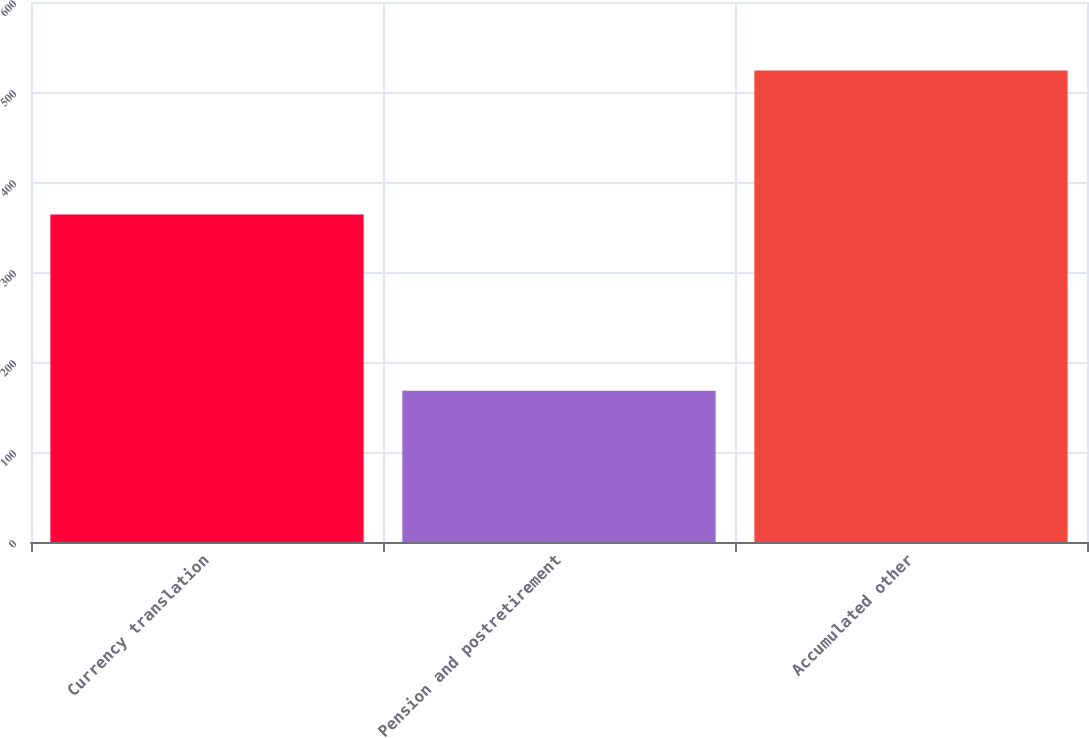<chart> <loc_0><loc_0><loc_500><loc_500><bar_chart><fcel>Currency translation<fcel>Pension and postretirement<fcel>Accumulated other<nl><fcel>364<fcel>168<fcel>524<nl></chart> 